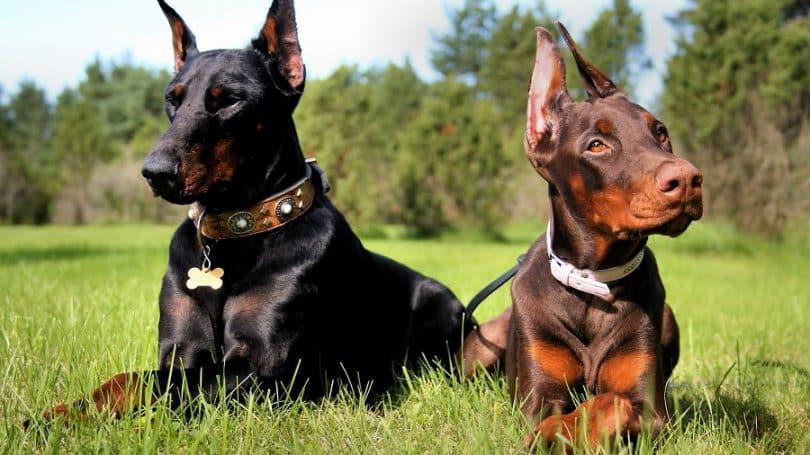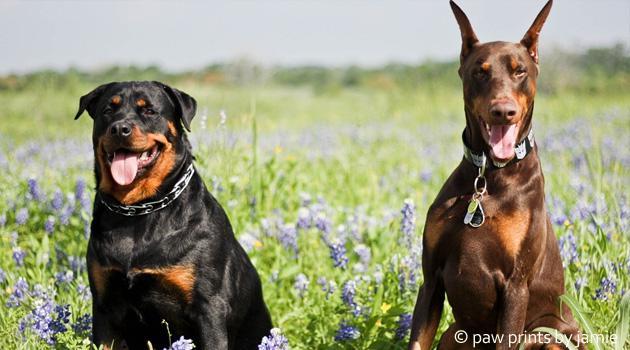The first image is the image on the left, the second image is the image on the right. For the images shown, is this caption "At least three dogs are dobermans with upright pointy ears, and no dogs are standing up with all four paws on the ground." true? Answer yes or no. Yes. The first image is the image on the left, the second image is the image on the right. Assess this claim about the two images: "Two dogs are standing in the grass in the image on the left.". Correct or not? Answer yes or no. No. 